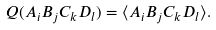<formula> <loc_0><loc_0><loc_500><loc_500>Q ( A _ { i } B _ { j } C _ { k } D _ { l } ) = \langle A _ { i } B _ { j } C _ { k } D _ { l } \rangle .</formula> 